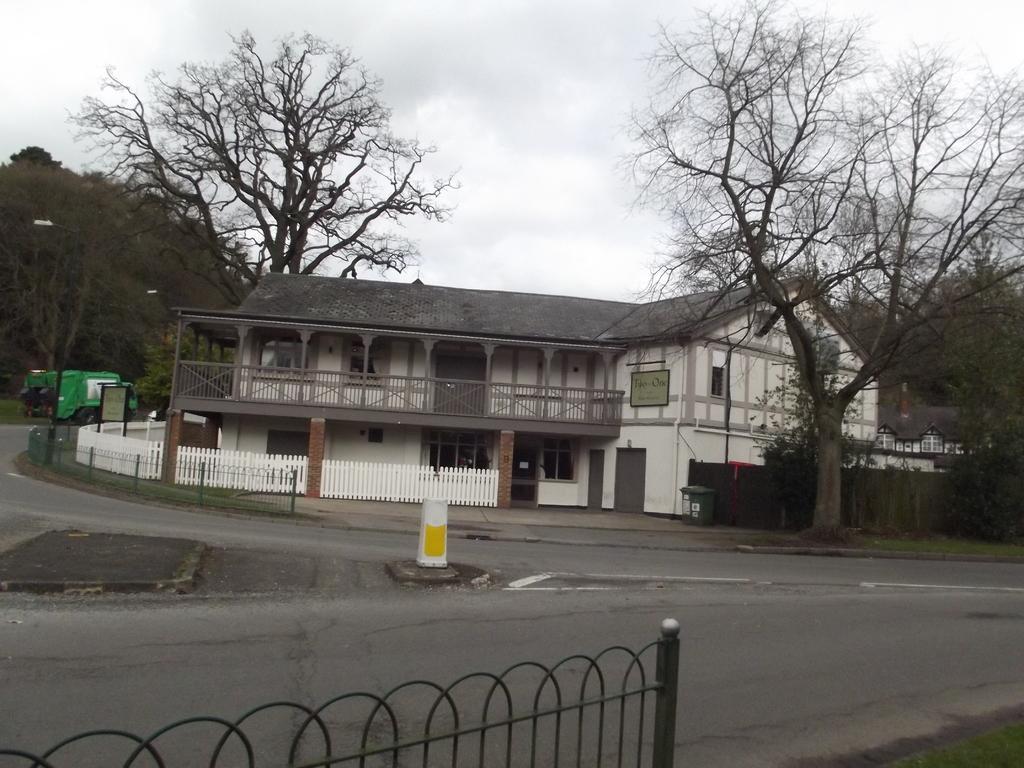How would you summarize this image in a sentence or two? In this image I can see at the bottom there is an iron grill and the road. In the middle there is a house, there are trees on either side of this image, at the top there is the cloudy sky. 